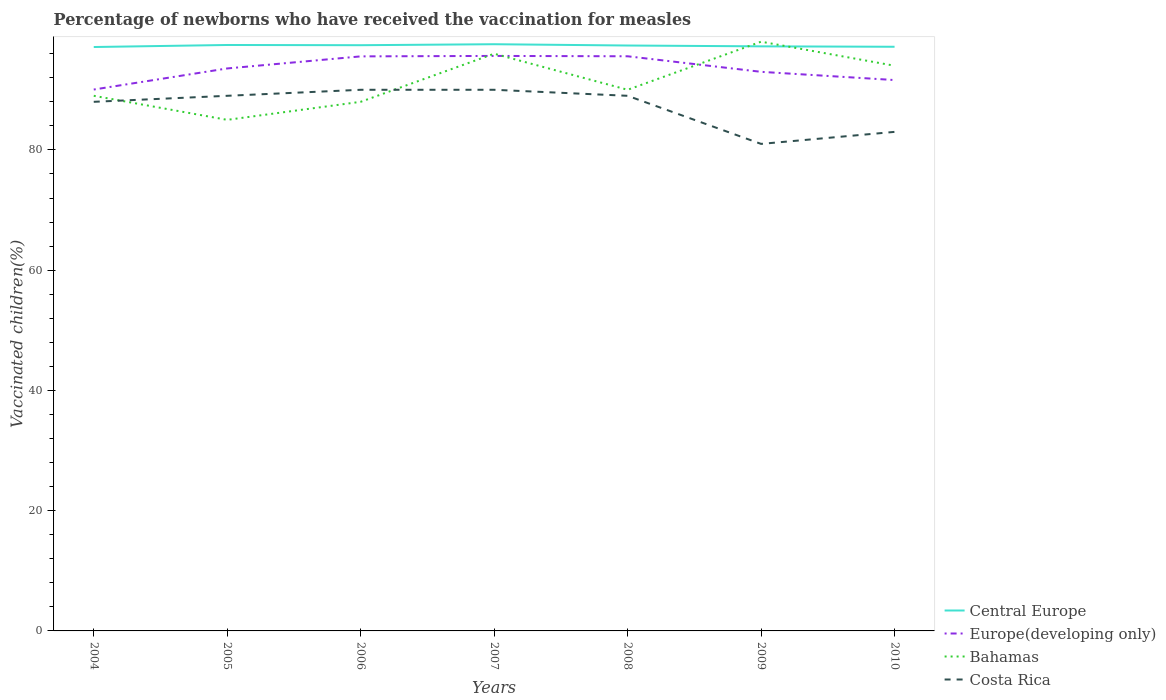How many different coloured lines are there?
Offer a terse response. 4. Across all years, what is the maximum percentage of vaccinated children in Central Europe?
Offer a terse response. 97.11. What is the total percentage of vaccinated children in Central Europe in the graph?
Offer a very short reply. -0.34. What is the difference between the highest and the second highest percentage of vaccinated children in Europe(developing only)?
Make the answer very short. 5.59. How many years are there in the graph?
Give a very brief answer. 7. Are the values on the major ticks of Y-axis written in scientific E-notation?
Your response must be concise. No. Does the graph contain grids?
Offer a very short reply. No. How are the legend labels stacked?
Provide a short and direct response. Vertical. What is the title of the graph?
Ensure brevity in your answer.  Percentage of newborns who have received the vaccination for measles. Does "Benin" appear as one of the legend labels in the graph?
Your response must be concise. No. What is the label or title of the Y-axis?
Offer a terse response. Vaccinated children(%). What is the Vaccinated children(%) in Central Europe in 2004?
Your answer should be very brief. 97.11. What is the Vaccinated children(%) in Europe(developing only) in 2004?
Offer a very short reply. 90.04. What is the Vaccinated children(%) in Bahamas in 2004?
Make the answer very short. 89. What is the Vaccinated children(%) of Central Europe in 2005?
Your response must be concise. 97.45. What is the Vaccinated children(%) in Europe(developing only) in 2005?
Keep it short and to the point. 93.55. What is the Vaccinated children(%) of Bahamas in 2005?
Ensure brevity in your answer.  85. What is the Vaccinated children(%) of Costa Rica in 2005?
Keep it short and to the point. 89. What is the Vaccinated children(%) in Central Europe in 2006?
Offer a terse response. 97.41. What is the Vaccinated children(%) in Europe(developing only) in 2006?
Offer a terse response. 95.56. What is the Vaccinated children(%) in Costa Rica in 2006?
Give a very brief answer. 90. What is the Vaccinated children(%) in Central Europe in 2007?
Provide a short and direct response. 97.58. What is the Vaccinated children(%) in Europe(developing only) in 2007?
Keep it short and to the point. 95.63. What is the Vaccinated children(%) of Bahamas in 2007?
Offer a terse response. 96. What is the Vaccinated children(%) of Central Europe in 2008?
Make the answer very short. 97.36. What is the Vaccinated children(%) in Europe(developing only) in 2008?
Give a very brief answer. 95.57. What is the Vaccinated children(%) in Costa Rica in 2008?
Offer a very short reply. 89. What is the Vaccinated children(%) in Central Europe in 2009?
Give a very brief answer. 97.23. What is the Vaccinated children(%) of Europe(developing only) in 2009?
Your response must be concise. 92.99. What is the Vaccinated children(%) in Costa Rica in 2009?
Make the answer very short. 81. What is the Vaccinated children(%) in Central Europe in 2010?
Offer a very short reply. 97.16. What is the Vaccinated children(%) of Europe(developing only) in 2010?
Give a very brief answer. 91.62. What is the Vaccinated children(%) in Bahamas in 2010?
Your answer should be very brief. 94. Across all years, what is the maximum Vaccinated children(%) in Central Europe?
Offer a terse response. 97.58. Across all years, what is the maximum Vaccinated children(%) in Europe(developing only)?
Offer a terse response. 95.63. Across all years, what is the maximum Vaccinated children(%) in Bahamas?
Offer a terse response. 98. Across all years, what is the maximum Vaccinated children(%) of Costa Rica?
Provide a succinct answer. 90. Across all years, what is the minimum Vaccinated children(%) of Central Europe?
Provide a succinct answer. 97.11. Across all years, what is the minimum Vaccinated children(%) in Europe(developing only)?
Your answer should be very brief. 90.04. Across all years, what is the minimum Vaccinated children(%) of Costa Rica?
Make the answer very short. 81. What is the total Vaccinated children(%) of Central Europe in the graph?
Offer a terse response. 681.3. What is the total Vaccinated children(%) in Europe(developing only) in the graph?
Make the answer very short. 654.96. What is the total Vaccinated children(%) in Bahamas in the graph?
Your response must be concise. 640. What is the total Vaccinated children(%) in Costa Rica in the graph?
Offer a very short reply. 610. What is the difference between the Vaccinated children(%) of Central Europe in 2004 and that in 2005?
Provide a succinct answer. -0.34. What is the difference between the Vaccinated children(%) in Europe(developing only) in 2004 and that in 2005?
Provide a succinct answer. -3.51. What is the difference between the Vaccinated children(%) of Costa Rica in 2004 and that in 2005?
Provide a succinct answer. -1. What is the difference between the Vaccinated children(%) of Central Europe in 2004 and that in 2006?
Keep it short and to the point. -0.3. What is the difference between the Vaccinated children(%) in Europe(developing only) in 2004 and that in 2006?
Make the answer very short. -5.52. What is the difference between the Vaccinated children(%) of Central Europe in 2004 and that in 2007?
Give a very brief answer. -0.47. What is the difference between the Vaccinated children(%) in Europe(developing only) in 2004 and that in 2007?
Give a very brief answer. -5.59. What is the difference between the Vaccinated children(%) of Costa Rica in 2004 and that in 2007?
Ensure brevity in your answer.  -2. What is the difference between the Vaccinated children(%) in Central Europe in 2004 and that in 2008?
Make the answer very short. -0.25. What is the difference between the Vaccinated children(%) of Europe(developing only) in 2004 and that in 2008?
Offer a very short reply. -5.53. What is the difference between the Vaccinated children(%) of Central Europe in 2004 and that in 2009?
Provide a succinct answer. -0.11. What is the difference between the Vaccinated children(%) in Europe(developing only) in 2004 and that in 2009?
Provide a succinct answer. -2.95. What is the difference between the Vaccinated children(%) of Bahamas in 2004 and that in 2009?
Your answer should be compact. -9. What is the difference between the Vaccinated children(%) in Costa Rica in 2004 and that in 2009?
Keep it short and to the point. 7. What is the difference between the Vaccinated children(%) of Central Europe in 2004 and that in 2010?
Your response must be concise. -0.04. What is the difference between the Vaccinated children(%) in Europe(developing only) in 2004 and that in 2010?
Your response must be concise. -1.58. What is the difference between the Vaccinated children(%) of Costa Rica in 2004 and that in 2010?
Provide a short and direct response. 5. What is the difference between the Vaccinated children(%) of Central Europe in 2005 and that in 2006?
Offer a terse response. 0.04. What is the difference between the Vaccinated children(%) in Europe(developing only) in 2005 and that in 2006?
Your answer should be very brief. -2.01. What is the difference between the Vaccinated children(%) of Bahamas in 2005 and that in 2006?
Ensure brevity in your answer.  -3. What is the difference between the Vaccinated children(%) in Costa Rica in 2005 and that in 2006?
Offer a terse response. -1. What is the difference between the Vaccinated children(%) in Central Europe in 2005 and that in 2007?
Your answer should be very brief. -0.13. What is the difference between the Vaccinated children(%) of Europe(developing only) in 2005 and that in 2007?
Your response must be concise. -2.08. What is the difference between the Vaccinated children(%) in Costa Rica in 2005 and that in 2007?
Your answer should be very brief. -1. What is the difference between the Vaccinated children(%) of Central Europe in 2005 and that in 2008?
Provide a short and direct response. 0.09. What is the difference between the Vaccinated children(%) of Europe(developing only) in 2005 and that in 2008?
Your answer should be compact. -2.02. What is the difference between the Vaccinated children(%) of Bahamas in 2005 and that in 2008?
Offer a very short reply. -5. What is the difference between the Vaccinated children(%) of Costa Rica in 2005 and that in 2008?
Provide a succinct answer. 0. What is the difference between the Vaccinated children(%) of Central Europe in 2005 and that in 2009?
Your answer should be very brief. 0.23. What is the difference between the Vaccinated children(%) of Europe(developing only) in 2005 and that in 2009?
Give a very brief answer. 0.56. What is the difference between the Vaccinated children(%) of Bahamas in 2005 and that in 2009?
Your answer should be compact. -13. What is the difference between the Vaccinated children(%) of Central Europe in 2005 and that in 2010?
Ensure brevity in your answer.  0.3. What is the difference between the Vaccinated children(%) of Europe(developing only) in 2005 and that in 2010?
Ensure brevity in your answer.  1.93. What is the difference between the Vaccinated children(%) of Central Europe in 2006 and that in 2007?
Offer a very short reply. -0.16. What is the difference between the Vaccinated children(%) of Europe(developing only) in 2006 and that in 2007?
Your answer should be compact. -0.08. What is the difference between the Vaccinated children(%) of Bahamas in 2006 and that in 2007?
Give a very brief answer. -8. What is the difference between the Vaccinated children(%) of Costa Rica in 2006 and that in 2007?
Keep it short and to the point. 0. What is the difference between the Vaccinated children(%) of Central Europe in 2006 and that in 2008?
Provide a succinct answer. 0.05. What is the difference between the Vaccinated children(%) in Europe(developing only) in 2006 and that in 2008?
Offer a terse response. -0.02. What is the difference between the Vaccinated children(%) in Bahamas in 2006 and that in 2008?
Offer a terse response. -2. What is the difference between the Vaccinated children(%) in Costa Rica in 2006 and that in 2008?
Ensure brevity in your answer.  1. What is the difference between the Vaccinated children(%) of Central Europe in 2006 and that in 2009?
Your response must be concise. 0.19. What is the difference between the Vaccinated children(%) in Europe(developing only) in 2006 and that in 2009?
Keep it short and to the point. 2.57. What is the difference between the Vaccinated children(%) in Bahamas in 2006 and that in 2009?
Ensure brevity in your answer.  -10. What is the difference between the Vaccinated children(%) in Costa Rica in 2006 and that in 2009?
Your response must be concise. 9. What is the difference between the Vaccinated children(%) in Central Europe in 2006 and that in 2010?
Give a very brief answer. 0.26. What is the difference between the Vaccinated children(%) in Europe(developing only) in 2006 and that in 2010?
Make the answer very short. 3.94. What is the difference between the Vaccinated children(%) in Bahamas in 2006 and that in 2010?
Keep it short and to the point. -6. What is the difference between the Vaccinated children(%) in Costa Rica in 2006 and that in 2010?
Your answer should be compact. 7. What is the difference between the Vaccinated children(%) in Central Europe in 2007 and that in 2008?
Ensure brevity in your answer.  0.22. What is the difference between the Vaccinated children(%) in Europe(developing only) in 2007 and that in 2008?
Your response must be concise. 0.06. What is the difference between the Vaccinated children(%) of Bahamas in 2007 and that in 2008?
Ensure brevity in your answer.  6. What is the difference between the Vaccinated children(%) in Costa Rica in 2007 and that in 2008?
Your answer should be very brief. 1. What is the difference between the Vaccinated children(%) in Central Europe in 2007 and that in 2009?
Your response must be concise. 0.35. What is the difference between the Vaccinated children(%) in Europe(developing only) in 2007 and that in 2009?
Your answer should be compact. 2.65. What is the difference between the Vaccinated children(%) in Central Europe in 2007 and that in 2010?
Give a very brief answer. 0.42. What is the difference between the Vaccinated children(%) in Europe(developing only) in 2007 and that in 2010?
Provide a short and direct response. 4.01. What is the difference between the Vaccinated children(%) of Central Europe in 2008 and that in 2009?
Provide a succinct answer. 0.14. What is the difference between the Vaccinated children(%) in Europe(developing only) in 2008 and that in 2009?
Ensure brevity in your answer.  2.59. What is the difference between the Vaccinated children(%) in Bahamas in 2008 and that in 2009?
Provide a succinct answer. -8. What is the difference between the Vaccinated children(%) in Costa Rica in 2008 and that in 2009?
Offer a very short reply. 8. What is the difference between the Vaccinated children(%) in Central Europe in 2008 and that in 2010?
Offer a terse response. 0.21. What is the difference between the Vaccinated children(%) of Europe(developing only) in 2008 and that in 2010?
Your answer should be compact. 3.95. What is the difference between the Vaccinated children(%) of Costa Rica in 2008 and that in 2010?
Keep it short and to the point. 6. What is the difference between the Vaccinated children(%) of Central Europe in 2009 and that in 2010?
Provide a short and direct response. 0.07. What is the difference between the Vaccinated children(%) of Europe(developing only) in 2009 and that in 2010?
Offer a terse response. 1.37. What is the difference between the Vaccinated children(%) of Bahamas in 2009 and that in 2010?
Provide a succinct answer. 4. What is the difference between the Vaccinated children(%) in Central Europe in 2004 and the Vaccinated children(%) in Europe(developing only) in 2005?
Offer a very short reply. 3.56. What is the difference between the Vaccinated children(%) of Central Europe in 2004 and the Vaccinated children(%) of Bahamas in 2005?
Provide a short and direct response. 12.11. What is the difference between the Vaccinated children(%) in Central Europe in 2004 and the Vaccinated children(%) in Costa Rica in 2005?
Provide a short and direct response. 8.11. What is the difference between the Vaccinated children(%) in Europe(developing only) in 2004 and the Vaccinated children(%) in Bahamas in 2005?
Offer a terse response. 5.04. What is the difference between the Vaccinated children(%) in Europe(developing only) in 2004 and the Vaccinated children(%) in Costa Rica in 2005?
Provide a succinct answer. 1.04. What is the difference between the Vaccinated children(%) of Central Europe in 2004 and the Vaccinated children(%) of Europe(developing only) in 2006?
Provide a short and direct response. 1.56. What is the difference between the Vaccinated children(%) of Central Europe in 2004 and the Vaccinated children(%) of Bahamas in 2006?
Your response must be concise. 9.11. What is the difference between the Vaccinated children(%) of Central Europe in 2004 and the Vaccinated children(%) of Costa Rica in 2006?
Keep it short and to the point. 7.11. What is the difference between the Vaccinated children(%) in Europe(developing only) in 2004 and the Vaccinated children(%) in Bahamas in 2006?
Offer a very short reply. 2.04. What is the difference between the Vaccinated children(%) of Europe(developing only) in 2004 and the Vaccinated children(%) of Costa Rica in 2006?
Your answer should be very brief. 0.04. What is the difference between the Vaccinated children(%) in Central Europe in 2004 and the Vaccinated children(%) in Europe(developing only) in 2007?
Ensure brevity in your answer.  1.48. What is the difference between the Vaccinated children(%) in Central Europe in 2004 and the Vaccinated children(%) in Bahamas in 2007?
Offer a terse response. 1.11. What is the difference between the Vaccinated children(%) of Central Europe in 2004 and the Vaccinated children(%) of Costa Rica in 2007?
Make the answer very short. 7.11. What is the difference between the Vaccinated children(%) in Europe(developing only) in 2004 and the Vaccinated children(%) in Bahamas in 2007?
Offer a very short reply. -5.96. What is the difference between the Vaccinated children(%) in Europe(developing only) in 2004 and the Vaccinated children(%) in Costa Rica in 2007?
Ensure brevity in your answer.  0.04. What is the difference between the Vaccinated children(%) of Bahamas in 2004 and the Vaccinated children(%) of Costa Rica in 2007?
Offer a very short reply. -1. What is the difference between the Vaccinated children(%) of Central Europe in 2004 and the Vaccinated children(%) of Europe(developing only) in 2008?
Your answer should be compact. 1.54. What is the difference between the Vaccinated children(%) in Central Europe in 2004 and the Vaccinated children(%) in Bahamas in 2008?
Your answer should be compact. 7.11. What is the difference between the Vaccinated children(%) of Central Europe in 2004 and the Vaccinated children(%) of Costa Rica in 2008?
Ensure brevity in your answer.  8.11. What is the difference between the Vaccinated children(%) in Europe(developing only) in 2004 and the Vaccinated children(%) in Bahamas in 2008?
Provide a short and direct response. 0.04. What is the difference between the Vaccinated children(%) in Europe(developing only) in 2004 and the Vaccinated children(%) in Costa Rica in 2008?
Give a very brief answer. 1.04. What is the difference between the Vaccinated children(%) of Bahamas in 2004 and the Vaccinated children(%) of Costa Rica in 2008?
Give a very brief answer. 0. What is the difference between the Vaccinated children(%) of Central Europe in 2004 and the Vaccinated children(%) of Europe(developing only) in 2009?
Ensure brevity in your answer.  4.13. What is the difference between the Vaccinated children(%) of Central Europe in 2004 and the Vaccinated children(%) of Bahamas in 2009?
Provide a succinct answer. -0.89. What is the difference between the Vaccinated children(%) of Central Europe in 2004 and the Vaccinated children(%) of Costa Rica in 2009?
Offer a terse response. 16.11. What is the difference between the Vaccinated children(%) of Europe(developing only) in 2004 and the Vaccinated children(%) of Bahamas in 2009?
Your response must be concise. -7.96. What is the difference between the Vaccinated children(%) of Europe(developing only) in 2004 and the Vaccinated children(%) of Costa Rica in 2009?
Offer a very short reply. 9.04. What is the difference between the Vaccinated children(%) in Central Europe in 2004 and the Vaccinated children(%) in Europe(developing only) in 2010?
Give a very brief answer. 5.49. What is the difference between the Vaccinated children(%) in Central Europe in 2004 and the Vaccinated children(%) in Bahamas in 2010?
Provide a short and direct response. 3.11. What is the difference between the Vaccinated children(%) of Central Europe in 2004 and the Vaccinated children(%) of Costa Rica in 2010?
Ensure brevity in your answer.  14.11. What is the difference between the Vaccinated children(%) of Europe(developing only) in 2004 and the Vaccinated children(%) of Bahamas in 2010?
Keep it short and to the point. -3.96. What is the difference between the Vaccinated children(%) in Europe(developing only) in 2004 and the Vaccinated children(%) in Costa Rica in 2010?
Your response must be concise. 7.04. What is the difference between the Vaccinated children(%) of Central Europe in 2005 and the Vaccinated children(%) of Europe(developing only) in 2006?
Provide a short and direct response. 1.9. What is the difference between the Vaccinated children(%) of Central Europe in 2005 and the Vaccinated children(%) of Bahamas in 2006?
Ensure brevity in your answer.  9.45. What is the difference between the Vaccinated children(%) of Central Europe in 2005 and the Vaccinated children(%) of Costa Rica in 2006?
Your answer should be compact. 7.45. What is the difference between the Vaccinated children(%) in Europe(developing only) in 2005 and the Vaccinated children(%) in Bahamas in 2006?
Your answer should be very brief. 5.55. What is the difference between the Vaccinated children(%) in Europe(developing only) in 2005 and the Vaccinated children(%) in Costa Rica in 2006?
Offer a very short reply. 3.55. What is the difference between the Vaccinated children(%) of Central Europe in 2005 and the Vaccinated children(%) of Europe(developing only) in 2007?
Offer a very short reply. 1.82. What is the difference between the Vaccinated children(%) in Central Europe in 2005 and the Vaccinated children(%) in Bahamas in 2007?
Your answer should be compact. 1.45. What is the difference between the Vaccinated children(%) in Central Europe in 2005 and the Vaccinated children(%) in Costa Rica in 2007?
Make the answer very short. 7.45. What is the difference between the Vaccinated children(%) in Europe(developing only) in 2005 and the Vaccinated children(%) in Bahamas in 2007?
Provide a succinct answer. -2.45. What is the difference between the Vaccinated children(%) of Europe(developing only) in 2005 and the Vaccinated children(%) of Costa Rica in 2007?
Provide a succinct answer. 3.55. What is the difference between the Vaccinated children(%) in Bahamas in 2005 and the Vaccinated children(%) in Costa Rica in 2007?
Your answer should be very brief. -5. What is the difference between the Vaccinated children(%) in Central Europe in 2005 and the Vaccinated children(%) in Europe(developing only) in 2008?
Give a very brief answer. 1.88. What is the difference between the Vaccinated children(%) in Central Europe in 2005 and the Vaccinated children(%) in Bahamas in 2008?
Make the answer very short. 7.45. What is the difference between the Vaccinated children(%) of Central Europe in 2005 and the Vaccinated children(%) of Costa Rica in 2008?
Make the answer very short. 8.45. What is the difference between the Vaccinated children(%) of Europe(developing only) in 2005 and the Vaccinated children(%) of Bahamas in 2008?
Give a very brief answer. 3.55. What is the difference between the Vaccinated children(%) of Europe(developing only) in 2005 and the Vaccinated children(%) of Costa Rica in 2008?
Ensure brevity in your answer.  4.55. What is the difference between the Vaccinated children(%) of Bahamas in 2005 and the Vaccinated children(%) of Costa Rica in 2008?
Provide a short and direct response. -4. What is the difference between the Vaccinated children(%) of Central Europe in 2005 and the Vaccinated children(%) of Europe(developing only) in 2009?
Provide a succinct answer. 4.47. What is the difference between the Vaccinated children(%) of Central Europe in 2005 and the Vaccinated children(%) of Bahamas in 2009?
Your answer should be compact. -0.55. What is the difference between the Vaccinated children(%) of Central Europe in 2005 and the Vaccinated children(%) of Costa Rica in 2009?
Give a very brief answer. 16.45. What is the difference between the Vaccinated children(%) of Europe(developing only) in 2005 and the Vaccinated children(%) of Bahamas in 2009?
Offer a very short reply. -4.45. What is the difference between the Vaccinated children(%) in Europe(developing only) in 2005 and the Vaccinated children(%) in Costa Rica in 2009?
Provide a succinct answer. 12.55. What is the difference between the Vaccinated children(%) in Bahamas in 2005 and the Vaccinated children(%) in Costa Rica in 2009?
Offer a very short reply. 4. What is the difference between the Vaccinated children(%) in Central Europe in 2005 and the Vaccinated children(%) in Europe(developing only) in 2010?
Offer a terse response. 5.83. What is the difference between the Vaccinated children(%) in Central Europe in 2005 and the Vaccinated children(%) in Bahamas in 2010?
Your answer should be compact. 3.45. What is the difference between the Vaccinated children(%) of Central Europe in 2005 and the Vaccinated children(%) of Costa Rica in 2010?
Provide a short and direct response. 14.45. What is the difference between the Vaccinated children(%) in Europe(developing only) in 2005 and the Vaccinated children(%) in Bahamas in 2010?
Offer a terse response. -0.45. What is the difference between the Vaccinated children(%) of Europe(developing only) in 2005 and the Vaccinated children(%) of Costa Rica in 2010?
Provide a short and direct response. 10.55. What is the difference between the Vaccinated children(%) in Bahamas in 2005 and the Vaccinated children(%) in Costa Rica in 2010?
Ensure brevity in your answer.  2. What is the difference between the Vaccinated children(%) in Central Europe in 2006 and the Vaccinated children(%) in Europe(developing only) in 2007?
Provide a short and direct response. 1.78. What is the difference between the Vaccinated children(%) of Central Europe in 2006 and the Vaccinated children(%) of Bahamas in 2007?
Ensure brevity in your answer.  1.41. What is the difference between the Vaccinated children(%) in Central Europe in 2006 and the Vaccinated children(%) in Costa Rica in 2007?
Ensure brevity in your answer.  7.41. What is the difference between the Vaccinated children(%) in Europe(developing only) in 2006 and the Vaccinated children(%) in Bahamas in 2007?
Give a very brief answer. -0.44. What is the difference between the Vaccinated children(%) in Europe(developing only) in 2006 and the Vaccinated children(%) in Costa Rica in 2007?
Your response must be concise. 5.56. What is the difference between the Vaccinated children(%) in Bahamas in 2006 and the Vaccinated children(%) in Costa Rica in 2007?
Make the answer very short. -2. What is the difference between the Vaccinated children(%) of Central Europe in 2006 and the Vaccinated children(%) of Europe(developing only) in 2008?
Your answer should be very brief. 1.84. What is the difference between the Vaccinated children(%) of Central Europe in 2006 and the Vaccinated children(%) of Bahamas in 2008?
Provide a short and direct response. 7.41. What is the difference between the Vaccinated children(%) in Central Europe in 2006 and the Vaccinated children(%) in Costa Rica in 2008?
Keep it short and to the point. 8.41. What is the difference between the Vaccinated children(%) in Europe(developing only) in 2006 and the Vaccinated children(%) in Bahamas in 2008?
Offer a very short reply. 5.56. What is the difference between the Vaccinated children(%) in Europe(developing only) in 2006 and the Vaccinated children(%) in Costa Rica in 2008?
Ensure brevity in your answer.  6.56. What is the difference between the Vaccinated children(%) in Central Europe in 2006 and the Vaccinated children(%) in Europe(developing only) in 2009?
Your answer should be very brief. 4.43. What is the difference between the Vaccinated children(%) in Central Europe in 2006 and the Vaccinated children(%) in Bahamas in 2009?
Offer a very short reply. -0.59. What is the difference between the Vaccinated children(%) of Central Europe in 2006 and the Vaccinated children(%) of Costa Rica in 2009?
Your answer should be very brief. 16.41. What is the difference between the Vaccinated children(%) in Europe(developing only) in 2006 and the Vaccinated children(%) in Bahamas in 2009?
Offer a very short reply. -2.44. What is the difference between the Vaccinated children(%) of Europe(developing only) in 2006 and the Vaccinated children(%) of Costa Rica in 2009?
Your answer should be very brief. 14.56. What is the difference between the Vaccinated children(%) in Bahamas in 2006 and the Vaccinated children(%) in Costa Rica in 2009?
Offer a very short reply. 7. What is the difference between the Vaccinated children(%) in Central Europe in 2006 and the Vaccinated children(%) in Europe(developing only) in 2010?
Offer a very short reply. 5.8. What is the difference between the Vaccinated children(%) of Central Europe in 2006 and the Vaccinated children(%) of Bahamas in 2010?
Offer a terse response. 3.41. What is the difference between the Vaccinated children(%) of Central Europe in 2006 and the Vaccinated children(%) of Costa Rica in 2010?
Make the answer very short. 14.41. What is the difference between the Vaccinated children(%) in Europe(developing only) in 2006 and the Vaccinated children(%) in Bahamas in 2010?
Your answer should be compact. 1.56. What is the difference between the Vaccinated children(%) of Europe(developing only) in 2006 and the Vaccinated children(%) of Costa Rica in 2010?
Provide a succinct answer. 12.56. What is the difference between the Vaccinated children(%) in Central Europe in 2007 and the Vaccinated children(%) in Europe(developing only) in 2008?
Your response must be concise. 2.01. What is the difference between the Vaccinated children(%) in Central Europe in 2007 and the Vaccinated children(%) in Bahamas in 2008?
Your answer should be compact. 7.58. What is the difference between the Vaccinated children(%) of Central Europe in 2007 and the Vaccinated children(%) of Costa Rica in 2008?
Provide a short and direct response. 8.58. What is the difference between the Vaccinated children(%) of Europe(developing only) in 2007 and the Vaccinated children(%) of Bahamas in 2008?
Give a very brief answer. 5.63. What is the difference between the Vaccinated children(%) in Europe(developing only) in 2007 and the Vaccinated children(%) in Costa Rica in 2008?
Keep it short and to the point. 6.63. What is the difference between the Vaccinated children(%) in Central Europe in 2007 and the Vaccinated children(%) in Europe(developing only) in 2009?
Ensure brevity in your answer.  4.59. What is the difference between the Vaccinated children(%) of Central Europe in 2007 and the Vaccinated children(%) of Bahamas in 2009?
Provide a succinct answer. -0.42. What is the difference between the Vaccinated children(%) in Central Europe in 2007 and the Vaccinated children(%) in Costa Rica in 2009?
Your answer should be compact. 16.58. What is the difference between the Vaccinated children(%) in Europe(developing only) in 2007 and the Vaccinated children(%) in Bahamas in 2009?
Your answer should be very brief. -2.37. What is the difference between the Vaccinated children(%) of Europe(developing only) in 2007 and the Vaccinated children(%) of Costa Rica in 2009?
Provide a succinct answer. 14.63. What is the difference between the Vaccinated children(%) of Central Europe in 2007 and the Vaccinated children(%) of Europe(developing only) in 2010?
Ensure brevity in your answer.  5.96. What is the difference between the Vaccinated children(%) of Central Europe in 2007 and the Vaccinated children(%) of Bahamas in 2010?
Offer a terse response. 3.58. What is the difference between the Vaccinated children(%) of Central Europe in 2007 and the Vaccinated children(%) of Costa Rica in 2010?
Your response must be concise. 14.58. What is the difference between the Vaccinated children(%) of Europe(developing only) in 2007 and the Vaccinated children(%) of Bahamas in 2010?
Provide a short and direct response. 1.63. What is the difference between the Vaccinated children(%) in Europe(developing only) in 2007 and the Vaccinated children(%) in Costa Rica in 2010?
Ensure brevity in your answer.  12.63. What is the difference between the Vaccinated children(%) of Central Europe in 2008 and the Vaccinated children(%) of Europe(developing only) in 2009?
Provide a short and direct response. 4.38. What is the difference between the Vaccinated children(%) of Central Europe in 2008 and the Vaccinated children(%) of Bahamas in 2009?
Ensure brevity in your answer.  -0.64. What is the difference between the Vaccinated children(%) of Central Europe in 2008 and the Vaccinated children(%) of Costa Rica in 2009?
Make the answer very short. 16.36. What is the difference between the Vaccinated children(%) in Europe(developing only) in 2008 and the Vaccinated children(%) in Bahamas in 2009?
Keep it short and to the point. -2.43. What is the difference between the Vaccinated children(%) of Europe(developing only) in 2008 and the Vaccinated children(%) of Costa Rica in 2009?
Your response must be concise. 14.57. What is the difference between the Vaccinated children(%) in Bahamas in 2008 and the Vaccinated children(%) in Costa Rica in 2009?
Give a very brief answer. 9. What is the difference between the Vaccinated children(%) in Central Europe in 2008 and the Vaccinated children(%) in Europe(developing only) in 2010?
Provide a short and direct response. 5.74. What is the difference between the Vaccinated children(%) in Central Europe in 2008 and the Vaccinated children(%) in Bahamas in 2010?
Ensure brevity in your answer.  3.36. What is the difference between the Vaccinated children(%) of Central Europe in 2008 and the Vaccinated children(%) of Costa Rica in 2010?
Give a very brief answer. 14.36. What is the difference between the Vaccinated children(%) in Europe(developing only) in 2008 and the Vaccinated children(%) in Bahamas in 2010?
Provide a succinct answer. 1.57. What is the difference between the Vaccinated children(%) in Europe(developing only) in 2008 and the Vaccinated children(%) in Costa Rica in 2010?
Give a very brief answer. 12.57. What is the difference between the Vaccinated children(%) of Bahamas in 2008 and the Vaccinated children(%) of Costa Rica in 2010?
Your response must be concise. 7. What is the difference between the Vaccinated children(%) of Central Europe in 2009 and the Vaccinated children(%) of Europe(developing only) in 2010?
Provide a short and direct response. 5.61. What is the difference between the Vaccinated children(%) in Central Europe in 2009 and the Vaccinated children(%) in Bahamas in 2010?
Make the answer very short. 3.23. What is the difference between the Vaccinated children(%) of Central Europe in 2009 and the Vaccinated children(%) of Costa Rica in 2010?
Keep it short and to the point. 14.23. What is the difference between the Vaccinated children(%) of Europe(developing only) in 2009 and the Vaccinated children(%) of Bahamas in 2010?
Your response must be concise. -1.01. What is the difference between the Vaccinated children(%) of Europe(developing only) in 2009 and the Vaccinated children(%) of Costa Rica in 2010?
Offer a terse response. 9.99. What is the difference between the Vaccinated children(%) in Bahamas in 2009 and the Vaccinated children(%) in Costa Rica in 2010?
Provide a succinct answer. 15. What is the average Vaccinated children(%) of Central Europe per year?
Your answer should be very brief. 97.33. What is the average Vaccinated children(%) in Europe(developing only) per year?
Your response must be concise. 93.57. What is the average Vaccinated children(%) of Bahamas per year?
Provide a short and direct response. 91.43. What is the average Vaccinated children(%) in Costa Rica per year?
Provide a succinct answer. 87.14. In the year 2004, what is the difference between the Vaccinated children(%) of Central Europe and Vaccinated children(%) of Europe(developing only)?
Provide a short and direct response. 7.07. In the year 2004, what is the difference between the Vaccinated children(%) of Central Europe and Vaccinated children(%) of Bahamas?
Offer a very short reply. 8.11. In the year 2004, what is the difference between the Vaccinated children(%) in Central Europe and Vaccinated children(%) in Costa Rica?
Your answer should be compact. 9.11. In the year 2004, what is the difference between the Vaccinated children(%) of Europe(developing only) and Vaccinated children(%) of Bahamas?
Offer a very short reply. 1.04. In the year 2004, what is the difference between the Vaccinated children(%) of Europe(developing only) and Vaccinated children(%) of Costa Rica?
Make the answer very short. 2.04. In the year 2005, what is the difference between the Vaccinated children(%) of Central Europe and Vaccinated children(%) of Europe(developing only)?
Provide a short and direct response. 3.9. In the year 2005, what is the difference between the Vaccinated children(%) of Central Europe and Vaccinated children(%) of Bahamas?
Ensure brevity in your answer.  12.45. In the year 2005, what is the difference between the Vaccinated children(%) of Central Europe and Vaccinated children(%) of Costa Rica?
Offer a terse response. 8.45. In the year 2005, what is the difference between the Vaccinated children(%) of Europe(developing only) and Vaccinated children(%) of Bahamas?
Provide a succinct answer. 8.55. In the year 2005, what is the difference between the Vaccinated children(%) of Europe(developing only) and Vaccinated children(%) of Costa Rica?
Your answer should be compact. 4.55. In the year 2006, what is the difference between the Vaccinated children(%) of Central Europe and Vaccinated children(%) of Europe(developing only)?
Provide a short and direct response. 1.86. In the year 2006, what is the difference between the Vaccinated children(%) of Central Europe and Vaccinated children(%) of Bahamas?
Give a very brief answer. 9.41. In the year 2006, what is the difference between the Vaccinated children(%) in Central Europe and Vaccinated children(%) in Costa Rica?
Offer a very short reply. 7.41. In the year 2006, what is the difference between the Vaccinated children(%) of Europe(developing only) and Vaccinated children(%) of Bahamas?
Offer a terse response. 7.56. In the year 2006, what is the difference between the Vaccinated children(%) of Europe(developing only) and Vaccinated children(%) of Costa Rica?
Offer a terse response. 5.56. In the year 2006, what is the difference between the Vaccinated children(%) of Bahamas and Vaccinated children(%) of Costa Rica?
Keep it short and to the point. -2. In the year 2007, what is the difference between the Vaccinated children(%) in Central Europe and Vaccinated children(%) in Europe(developing only)?
Provide a short and direct response. 1.95. In the year 2007, what is the difference between the Vaccinated children(%) of Central Europe and Vaccinated children(%) of Bahamas?
Ensure brevity in your answer.  1.58. In the year 2007, what is the difference between the Vaccinated children(%) of Central Europe and Vaccinated children(%) of Costa Rica?
Offer a very short reply. 7.58. In the year 2007, what is the difference between the Vaccinated children(%) in Europe(developing only) and Vaccinated children(%) in Bahamas?
Keep it short and to the point. -0.37. In the year 2007, what is the difference between the Vaccinated children(%) in Europe(developing only) and Vaccinated children(%) in Costa Rica?
Keep it short and to the point. 5.63. In the year 2007, what is the difference between the Vaccinated children(%) of Bahamas and Vaccinated children(%) of Costa Rica?
Your response must be concise. 6. In the year 2008, what is the difference between the Vaccinated children(%) of Central Europe and Vaccinated children(%) of Europe(developing only)?
Offer a very short reply. 1.79. In the year 2008, what is the difference between the Vaccinated children(%) in Central Europe and Vaccinated children(%) in Bahamas?
Provide a succinct answer. 7.36. In the year 2008, what is the difference between the Vaccinated children(%) in Central Europe and Vaccinated children(%) in Costa Rica?
Provide a short and direct response. 8.36. In the year 2008, what is the difference between the Vaccinated children(%) in Europe(developing only) and Vaccinated children(%) in Bahamas?
Give a very brief answer. 5.57. In the year 2008, what is the difference between the Vaccinated children(%) in Europe(developing only) and Vaccinated children(%) in Costa Rica?
Offer a terse response. 6.57. In the year 2009, what is the difference between the Vaccinated children(%) of Central Europe and Vaccinated children(%) of Europe(developing only)?
Offer a terse response. 4.24. In the year 2009, what is the difference between the Vaccinated children(%) in Central Europe and Vaccinated children(%) in Bahamas?
Offer a terse response. -0.77. In the year 2009, what is the difference between the Vaccinated children(%) in Central Europe and Vaccinated children(%) in Costa Rica?
Make the answer very short. 16.23. In the year 2009, what is the difference between the Vaccinated children(%) in Europe(developing only) and Vaccinated children(%) in Bahamas?
Ensure brevity in your answer.  -5.01. In the year 2009, what is the difference between the Vaccinated children(%) in Europe(developing only) and Vaccinated children(%) in Costa Rica?
Give a very brief answer. 11.99. In the year 2009, what is the difference between the Vaccinated children(%) in Bahamas and Vaccinated children(%) in Costa Rica?
Keep it short and to the point. 17. In the year 2010, what is the difference between the Vaccinated children(%) in Central Europe and Vaccinated children(%) in Europe(developing only)?
Keep it short and to the point. 5.54. In the year 2010, what is the difference between the Vaccinated children(%) in Central Europe and Vaccinated children(%) in Bahamas?
Offer a very short reply. 3.16. In the year 2010, what is the difference between the Vaccinated children(%) in Central Europe and Vaccinated children(%) in Costa Rica?
Keep it short and to the point. 14.16. In the year 2010, what is the difference between the Vaccinated children(%) in Europe(developing only) and Vaccinated children(%) in Bahamas?
Your answer should be very brief. -2.38. In the year 2010, what is the difference between the Vaccinated children(%) of Europe(developing only) and Vaccinated children(%) of Costa Rica?
Keep it short and to the point. 8.62. What is the ratio of the Vaccinated children(%) of Europe(developing only) in 2004 to that in 2005?
Offer a terse response. 0.96. What is the ratio of the Vaccinated children(%) of Bahamas in 2004 to that in 2005?
Offer a very short reply. 1.05. What is the ratio of the Vaccinated children(%) of Costa Rica in 2004 to that in 2005?
Offer a very short reply. 0.99. What is the ratio of the Vaccinated children(%) in Europe(developing only) in 2004 to that in 2006?
Provide a short and direct response. 0.94. What is the ratio of the Vaccinated children(%) in Bahamas in 2004 to that in 2006?
Provide a succinct answer. 1.01. What is the ratio of the Vaccinated children(%) of Costa Rica in 2004 to that in 2006?
Keep it short and to the point. 0.98. What is the ratio of the Vaccinated children(%) in Central Europe in 2004 to that in 2007?
Provide a short and direct response. 1. What is the ratio of the Vaccinated children(%) of Europe(developing only) in 2004 to that in 2007?
Ensure brevity in your answer.  0.94. What is the ratio of the Vaccinated children(%) of Bahamas in 2004 to that in 2007?
Provide a short and direct response. 0.93. What is the ratio of the Vaccinated children(%) of Costa Rica in 2004 to that in 2007?
Your answer should be very brief. 0.98. What is the ratio of the Vaccinated children(%) in Europe(developing only) in 2004 to that in 2008?
Offer a very short reply. 0.94. What is the ratio of the Vaccinated children(%) of Bahamas in 2004 to that in 2008?
Your answer should be compact. 0.99. What is the ratio of the Vaccinated children(%) of Europe(developing only) in 2004 to that in 2009?
Offer a very short reply. 0.97. What is the ratio of the Vaccinated children(%) in Bahamas in 2004 to that in 2009?
Offer a very short reply. 0.91. What is the ratio of the Vaccinated children(%) of Costa Rica in 2004 to that in 2009?
Make the answer very short. 1.09. What is the ratio of the Vaccinated children(%) in Europe(developing only) in 2004 to that in 2010?
Your response must be concise. 0.98. What is the ratio of the Vaccinated children(%) of Bahamas in 2004 to that in 2010?
Provide a succinct answer. 0.95. What is the ratio of the Vaccinated children(%) in Costa Rica in 2004 to that in 2010?
Provide a succinct answer. 1.06. What is the ratio of the Vaccinated children(%) in Europe(developing only) in 2005 to that in 2006?
Give a very brief answer. 0.98. What is the ratio of the Vaccinated children(%) of Bahamas in 2005 to that in 2006?
Offer a terse response. 0.97. What is the ratio of the Vaccinated children(%) of Costa Rica in 2005 to that in 2006?
Ensure brevity in your answer.  0.99. What is the ratio of the Vaccinated children(%) of Europe(developing only) in 2005 to that in 2007?
Offer a very short reply. 0.98. What is the ratio of the Vaccinated children(%) of Bahamas in 2005 to that in 2007?
Offer a terse response. 0.89. What is the ratio of the Vaccinated children(%) in Costa Rica in 2005 to that in 2007?
Keep it short and to the point. 0.99. What is the ratio of the Vaccinated children(%) in Europe(developing only) in 2005 to that in 2008?
Provide a short and direct response. 0.98. What is the ratio of the Vaccinated children(%) in Bahamas in 2005 to that in 2008?
Make the answer very short. 0.94. What is the ratio of the Vaccinated children(%) in Central Europe in 2005 to that in 2009?
Your answer should be very brief. 1. What is the ratio of the Vaccinated children(%) of Europe(developing only) in 2005 to that in 2009?
Your answer should be very brief. 1.01. What is the ratio of the Vaccinated children(%) in Bahamas in 2005 to that in 2009?
Your response must be concise. 0.87. What is the ratio of the Vaccinated children(%) of Costa Rica in 2005 to that in 2009?
Ensure brevity in your answer.  1.1. What is the ratio of the Vaccinated children(%) of Central Europe in 2005 to that in 2010?
Give a very brief answer. 1. What is the ratio of the Vaccinated children(%) of Europe(developing only) in 2005 to that in 2010?
Offer a very short reply. 1.02. What is the ratio of the Vaccinated children(%) of Bahamas in 2005 to that in 2010?
Your answer should be very brief. 0.9. What is the ratio of the Vaccinated children(%) of Costa Rica in 2005 to that in 2010?
Your answer should be very brief. 1.07. What is the ratio of the Vaccinated children(%) in Central Europe in 2006 to that in 2007?
Offer a very short reply. 1. What is the ratio of the Vaccinated children(%) of Bahamas in 2006 to that in 2007?
Give a very brief answer. 0.92. What is the ratio of the Vaccinated children(%) of Costa Rica in 2006 to that in 2007?
Your response must be concise. 1. What is the ratio of the Vaccinated children(%) in Central Europe in 2006 to that in 2008?
Your response must be concise. 1. What is the ratio of the Vaccinated children(%) in Europe(developing only) in 2006 to that in 2008?
Offer a very short reply. 1. What is the ratio of the Vaccinated children(%) in Bahamas in 2006 to that in 2008?
Ensure brevity in your answer.  0.98. What is the ratio of the Vaccinated children(%) of Costa Rica in 2006 to that in 2008?
Offer a very short reply. 1.01. What is the ratio of the Vaccinated children(%) in Central Europe in 2006 to that in 2009?
Keep it short and to the point. 1. What is the ratio of the Vaccinated children(%) in Europe(developing only) in 2006 to that in 2009?
Give a very brief answer. 1.03. What is the ratio of the Vaccinated children(%) in Bahamas in 2006 to that in 2009?
Offer a very short reply. 0.9. What is the ratio of the Vaccinated children(%) in Europe(developing only) in 2006 to that in 2010?
Your answer should be very brief. 1.04. What is the ratio of the Vaccinated children(%) in Bahamas in 2006 to that in 2010?
Offer a terse response. 0.94. What is the ratio of the Vaccinated children(%) in Costa Rica in 2006 to that in 2010?
Ensure brevity in your answer.  1.08. What is the ratio of the Vaccinated children(%) of Central Europe in 2007 to that in 2008?
Keep it short and to the point. 1. What is the ratio of the Vaccinated children(%) in Europe(developing only) in 2007 to that in 2008?
Provide a succinct answer. 1. What is the ratio of the Vaccinated children(%) of Bahamas in 2007 to that in 2008?
Offer a very short reply. 1.07. What is the ratio of the Vaccinated children(%) of Costa Rica in 2007 to that in 2008?
Provide a succinct answer. 1.01. What is the ratio of the Vaccinated children(%) of Central Europe in 2007 to that in 2009?
Offer a very short reply. 1. What is the ratio of the Vaccinated children(%) of Europe(developing only) in 2007 to that in 2009?
Provide a succinct answer. 1.03. What is the ratio of the Vaccinated children(%) of Bahamas in 2007 to that in 2009?
Offer a very short reply. 0.98. What is the ratio of the Vaccinated children(%) in Costa Rica in 2007 to that in 2009?
Offer a terse response. 1.11. What is the ratio of the Vaccinated children(%) of Europe(developing only) in 2007 to that in 2010?
Keep it short and to the point. 1.04. What is the ratio of the Vaccinated children(%) of Bahamas in 2007 to that in 2010?
Make the answer very short. 1.02. What is the ratio of the Vaccinated children(%) in Costa Rica in 2007 to that in 2010?
Make the answer very short. 1.08. What is the ratio of the Vaccinated children(%) of Central Europe in 2008 to that in 2009?
Offer a terse response. 1. What is the ratio of the Vaccinated children(%) of Europe(developing only) in 2008 to that in 2009?
Make the answer very short. 1.03. What is the ratio of the Vaccinated children(%) of Bahamas in 2008 to that in 2009?
Make the answer very short. 0.92. What is the ratio of the Vaccinated children(%) in Costa Rica in 2008 to that in 2009?
Provide a short and direct response. 1.1. What is the ratio of the Vaccinated children(%) in Central Europe in 2008 to that in 2010?
Ensure brevity in your answer.  1. What is the ratio of the Vaccinated children(%) of Europe(developing only) in 2008 to that in 2010?
Your answer should be very brief. 1.04. What is the ratio of the Vaccinated children(%) of Bahamas in 2008 to that in 2010?
Offer a very short reply. 0.96. What is the ratio of the Vaccinated children(%) of Costa Rica in 2008 to that in 2010?
Ensure brevity in your answer.  1.07. What is the ratio of the Vaccinated children(%) in Europe(developing only) in 2009 to that in 2010?
Your answer should be very brief. 1.01. What is the ratio of the Vaccinated children(%) of Bahamas in 2009 to that in 2010?
Give a very brief answer. 1.04. What is the ratio of the Vaccinated children(%) in Costa Rica in 2009 to that in 2010?
Make the answer very short. 0.98. What is the difference between the highest and the second highest Vaccinated children(%) of Central Europe?
Keep it short and to the point. 0.13. What is the difference between the highest and the second highest Vaccinated children(%) in Europe(developing only)?
Offer a terse response. 0.06. What is the difference between the highest and the second highest Vaccinated children(%) of Costa Rica?
Give a very brief answer. 0. What is the difference between the highest and the lowest Vaccinated children(%) of Central Europe?
Your answer should be compact. 0.47. What is the difference between the highest and the lowest Vaccinated children(%) in Europe(developing only)?
Offer a very short reply. 5.59. What is the difference between the highest and the lowest Vaccinated children(%) of Bahamas?
Ensure brevity in your answer.  13. 